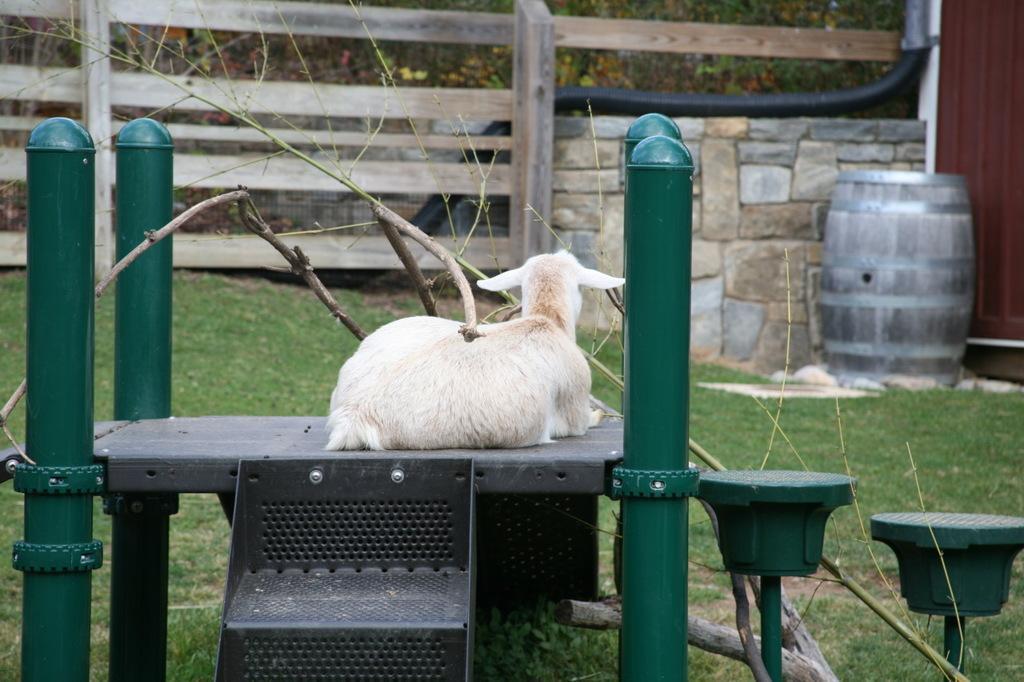Can you describe this image briefly? In this picture there is a goat who is sitting on the table, beside that we can see the stairs. In the background we can see wooden fencing and brick wall. On the right there is a wooden barrel near to the door. In front of the door we can see green grass. At the top we can see many trees. 